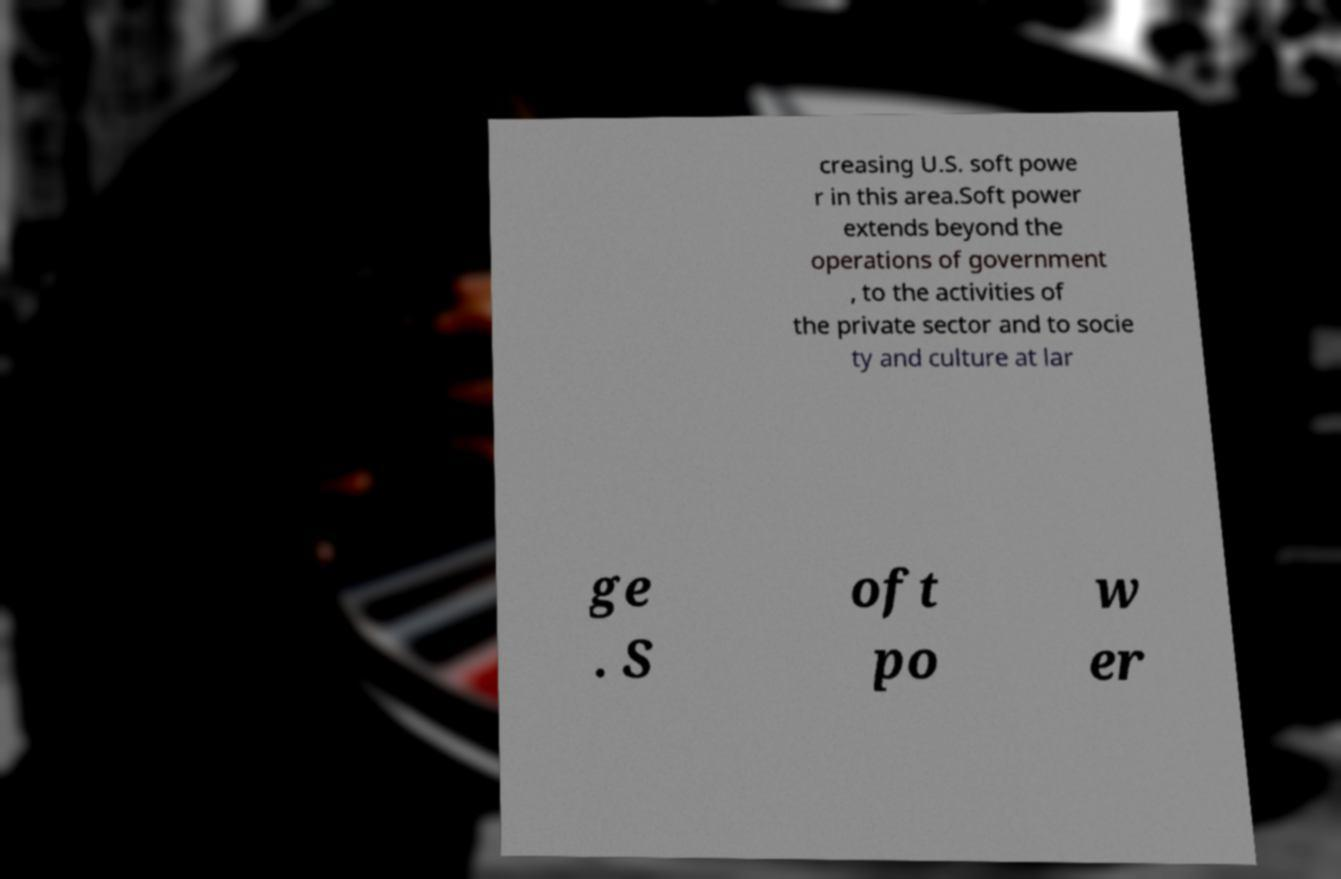There's text embedded in this image that I need extracted. Can you transcribe it verbatim? creasing U.S. soft powe r in this area.Soft power extends beyond the operations of government , to the activities of the private sector and to socie ty and culture at lar ge . S oft po w er 